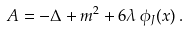Convert formula to latex. <formula><loc_0><loc_0><loc_500><loc_500>A = - \Delta + m ^ { 2 } + 6 \lambda \, \phi _ { J } ( x ) \, .</formula> 